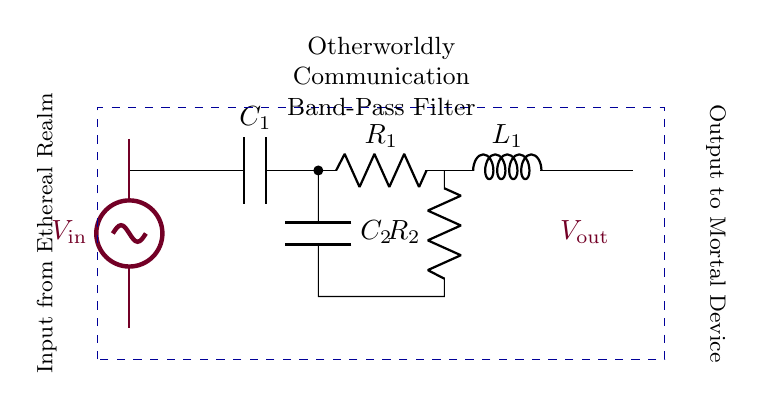What type of filter is represented in this circuit? The circuit diagram shows a band-pass filter, which is used to isolate specific frequencies. This is indicated by the combination of capacitors, resistors, and inductors arranged specifically for this function.
Answer: band-pass filter How many capacitors are present in this circuit? The circuit contains two capacitors, labeled as C1 and C2. They are clearly marked in the diagram, allowing easy identification.
Answer: 2 What is the output voltage labeled as in this circuit? The output voltage in the diagram is labeled as V out, which indicates the voltage that will be outputted from the filter to a connected device.
Answer: V out Which component is connected directly to the input voltage? The component connected directly to the input voltage V in is the capacitor C1. This is the first component in line after the input, allowing it to influence the filtering process.
Answer: C1 How is the output connected in this filter circuit? The output is connected through a short at the end of the circuit diagram to V out, indicating it is the point where the filtered signal exits the circuit.
Answer: V out What type of impedance element is positioned in series with the resistors in this filter? The impedance element in series with the resistors is an inductor, labeled L1. Inductors are used in filters to offer certain frequencies while attenuating others.
Answer: L1 What is the purpose of using two resistors in this configuration? The two resistors, R1 and R2, help to define the cutoff frequencies of the band-pass filter. They work alongside the capacitors and inductor to shape the filter's frequency response.
Answer: To define cutoff frequencies 